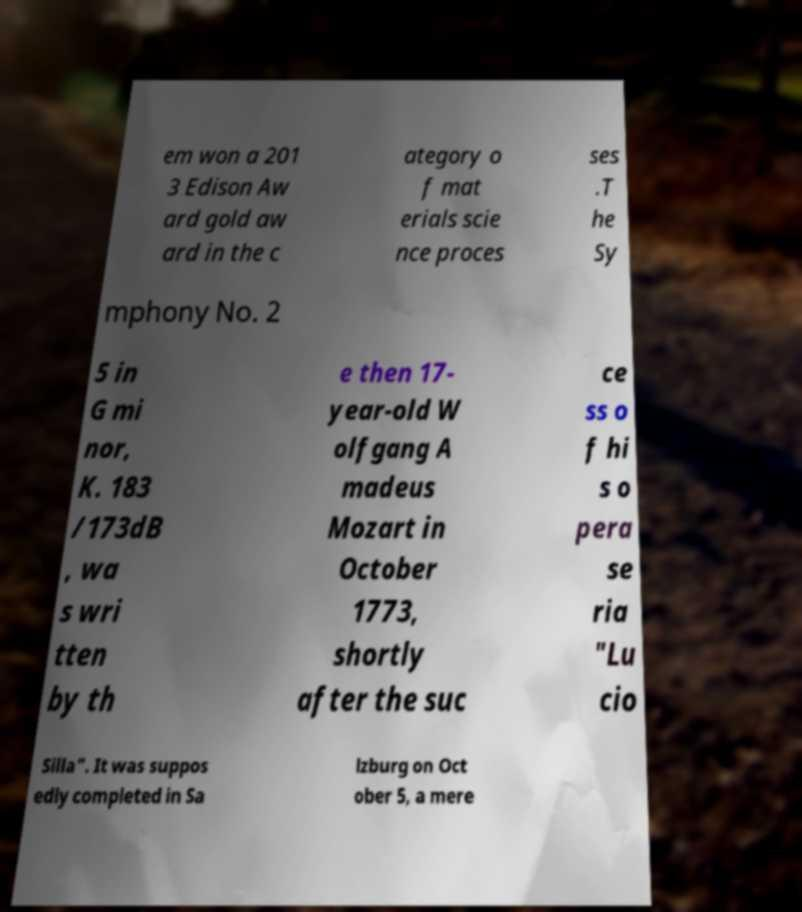What messages or text are displayed in this image? I need them in a readable, typed format. em won a 201 3 Edison Aw ard gold aw ard in the c ategory o f mat erials scie nce proces ses .T he Sy mphony No. 2 5 in G mi nor, K. 183 /173dB , wa s wri tten by th e then 17- year-old W olfgang A madeus Mozart in October 1773, shortly after the suc ce ss o f hi s o pera se ria "Lu cio Silla". It was suppos edly completed in Sa lzburg on Oct ober 5, a mere 